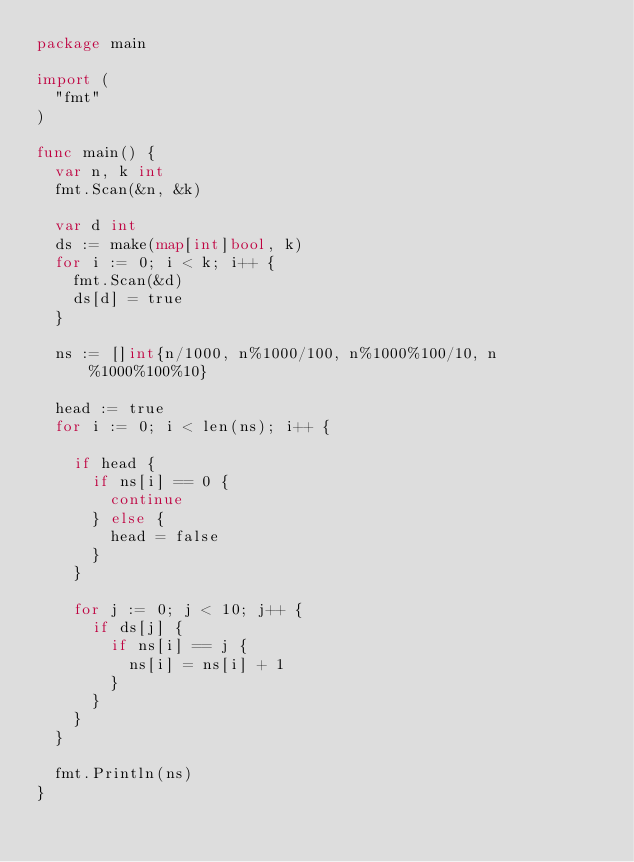Convert code to text. <code><loc_0><loc_0><loc_500><loc_500><_Go_>package main

import (
	"fmt"
)

func main() {
	var n, k int
	fmt.Scan(&n, &k)

	var d int
	ds := make(map[int]bool, k)
	for i := 0; i < k; i++ {
		fmt.Scan(&d)
		ds[d] = true
	}

	ns := []int{n/1000, n%1000/100, n%1000%100/10, n%1000%100%10}

	head := true
	for i := 0; i < len(ns); i++ {

		if head {
			if ns[i] == 0 {
				continue
			} else {
				head = false
			}
		}

		for j := 0; j < 10; j++ {
			if ds[j] {
				if ns[i] == j {
					ns[i] = ns[i] + 1
				}
			}
		}
	}

	fmt.Println(ns)
}
</code> 